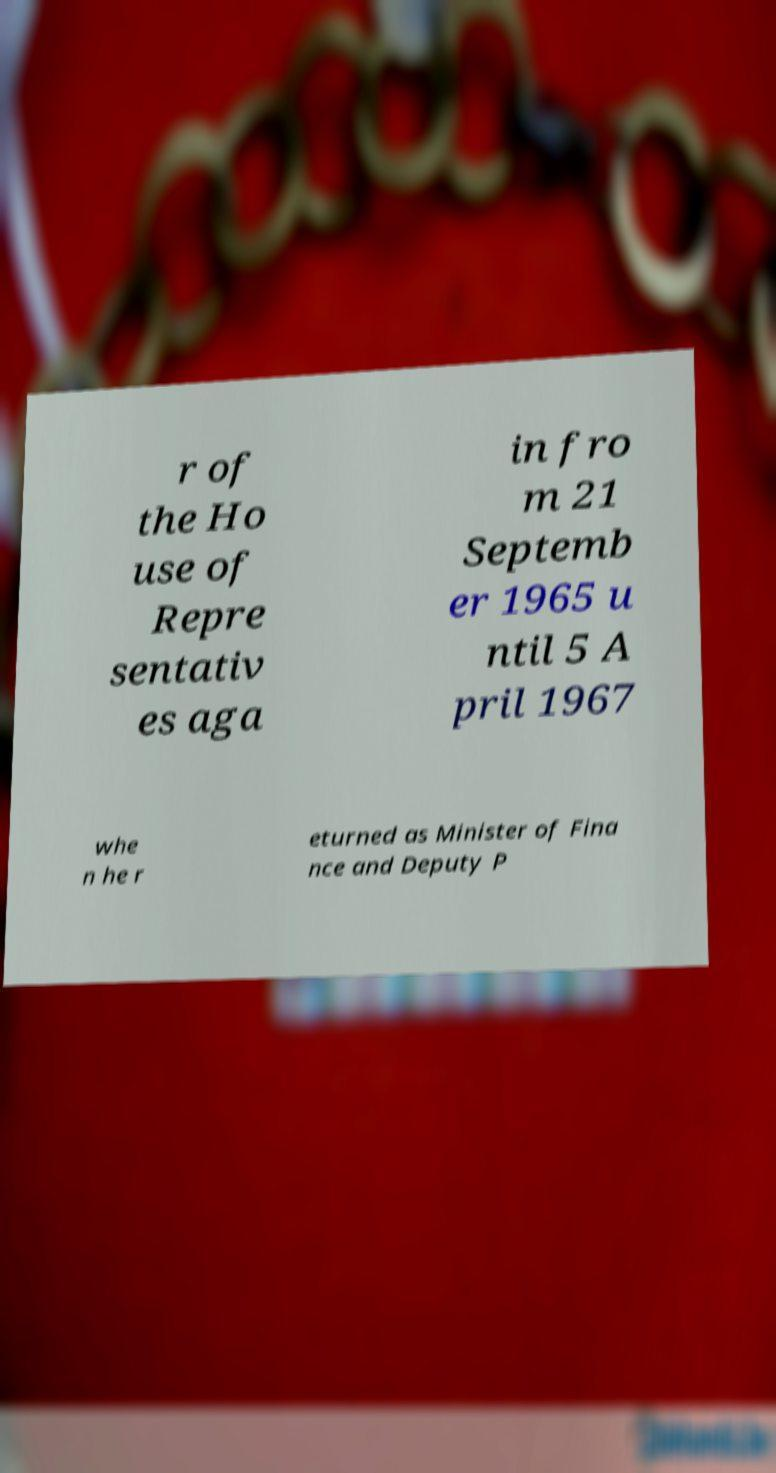Please read and relay the text visible in this image. What does it say? r of the Ho use of Repre sentativ es aga in fro m 21 Septemb er 1965 u ntil 5 A pril 1967 whe n he r eturned as Minister of Fina nce and Deputy P 